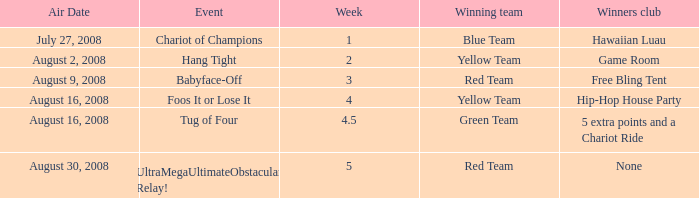How many weeks have a Winning team of yellow team, and an Event of foos it or lose it? 4.0. Would you mind parsing the complete table? {'header': ['Air Date', 'Event', 'Week', 'Winning team', 'Winners club'], 'rows': [['July 27, 2008', 'Chariot of Champions', '1', 'Blue Team', 'Hawaiian Luau'], ['August 2, 2008', 'Hang Tight', '2', 'Yellow Team', 'Game Room'], ['August 9, 2008', 'Babyface-Off', '3', 'Red Team', 'Free Bling Tent'], ['August 16, 2008', 'Foos It or Lose It', '4', 'Yellow Team', 'Hip-Hop House Party'], ['August 16, 2008', 'Tug of Four', '4.5', 'Green Team', '5 extra points and a Chariot Ride'], ['August 30, 2008', 'UltraMegaUltimateObstacular Relay!', '5', 'Red Team', 'None']]} 